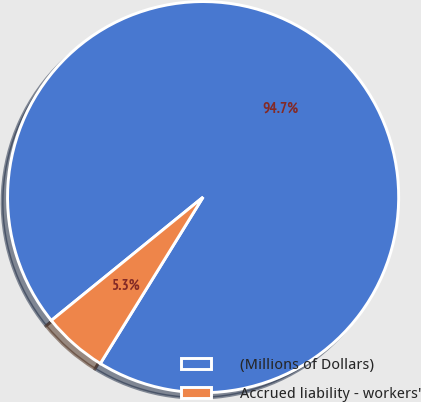<chart> <loc_0><loc_0><loc_500><loc_500><pie_chart><fcel>(Millions of Dollars)<fcel>Accrued liability - workers'<nl><fcel>94.67%<fcel>5.33%<nl></chart> 